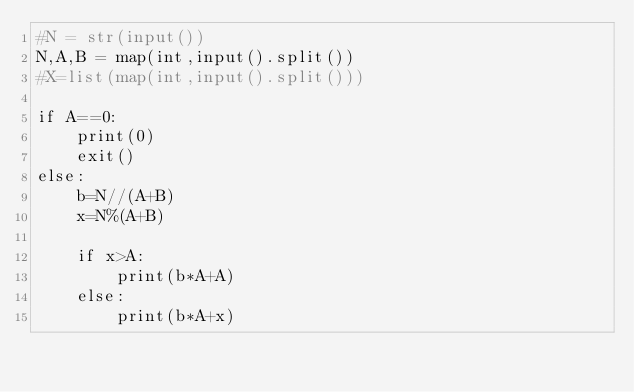Convert code to text. <code><loc_0><loc_0><loc_500><loc_500><_Python_>#N = str(input())
N,A,B = map(int,input().split())
#X=list(map(int,input().split()))

if A==0:
    print(0)
    exit()
else:
    b=N//(A+B)
    x=N%(A+B)

    if x>A:
        print(b*A+A)
    else:
        print(b*A+x)
</code> 